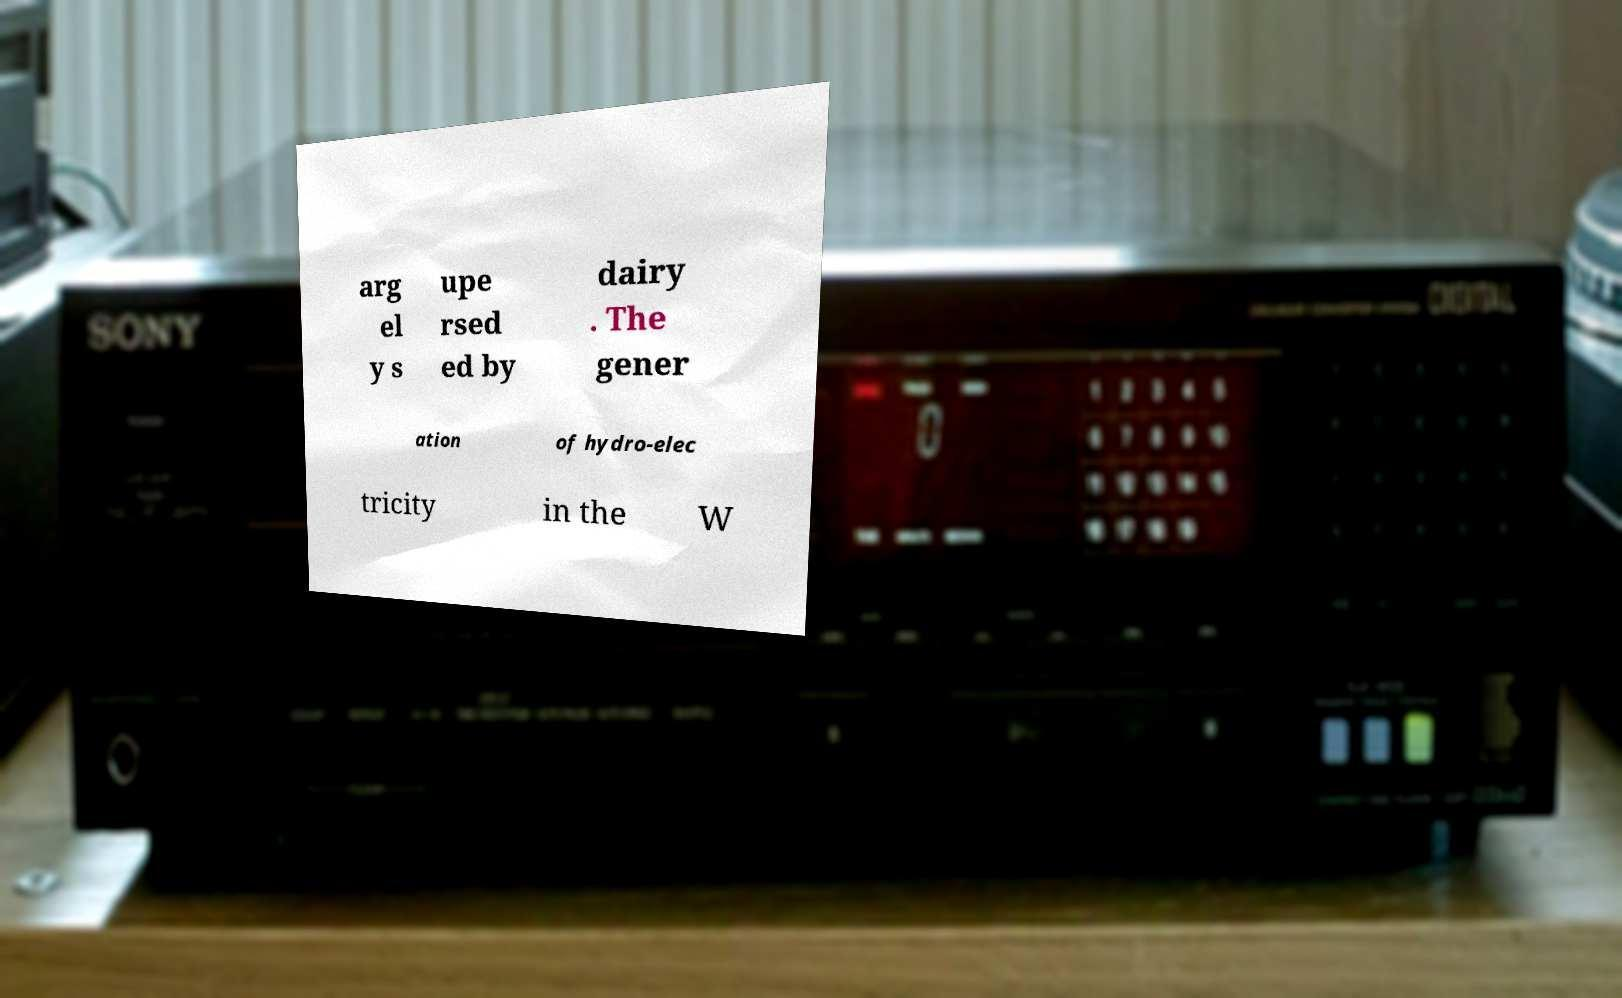Can you accurately transcribe the text from the provided image for me? arg el y s upe rsed ed by dairy . The gener ation of hydro-elec tricity in the W 